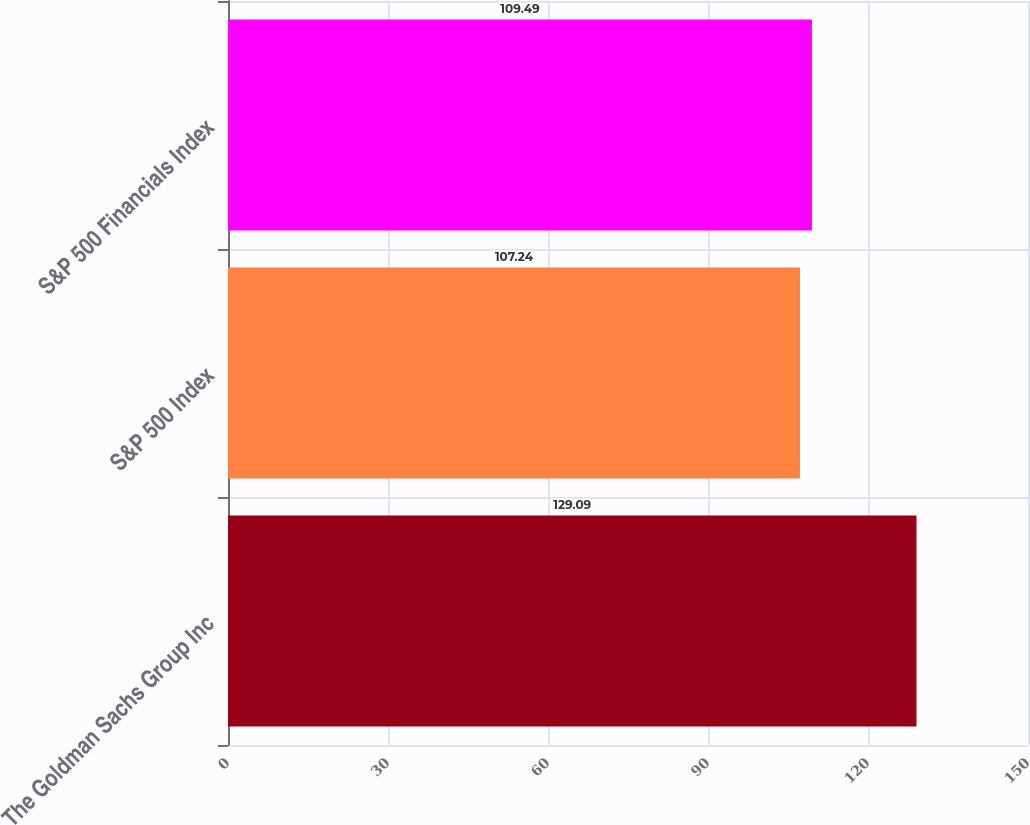Convert chart to OTSL. <chart><loc_0><loc_0><loc_500><loc_500><bar_chart><fcel>The Goldman Sachs Group Inc<fcel>S&P 500 Index<fcel>S&P 500 Financials Index<nl><fcel>129.09<fcel>107.24<fcel>109.49<nl></chart> 